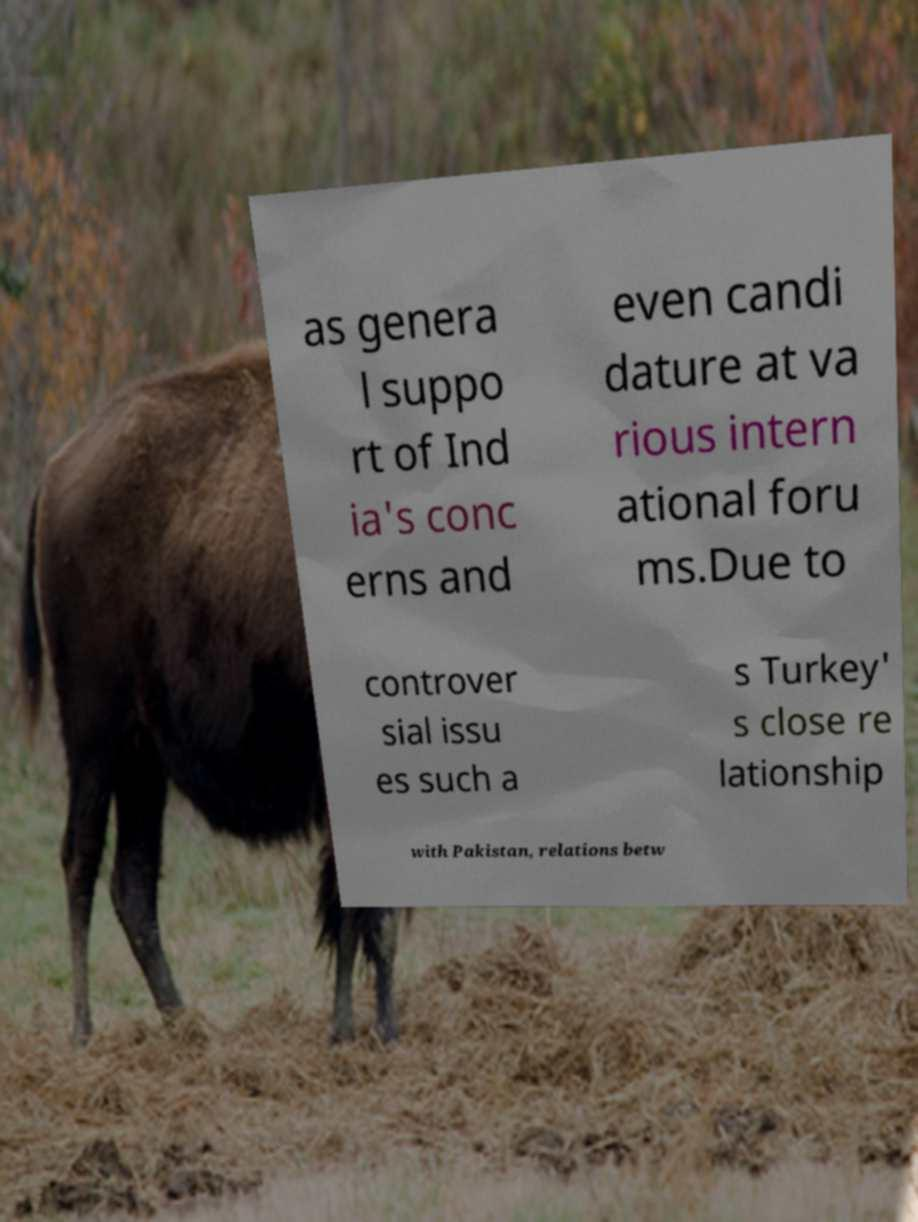There's text embedded in this image that I need extracted. Can you transcribe it verbatim? as genera l suppo rt of Ind ia's conc erns and even candi dature at va rious intern ational foru ms.Due to controver sial issu es such a s Turkey' s close re lationship with Pakistan, relations betw 